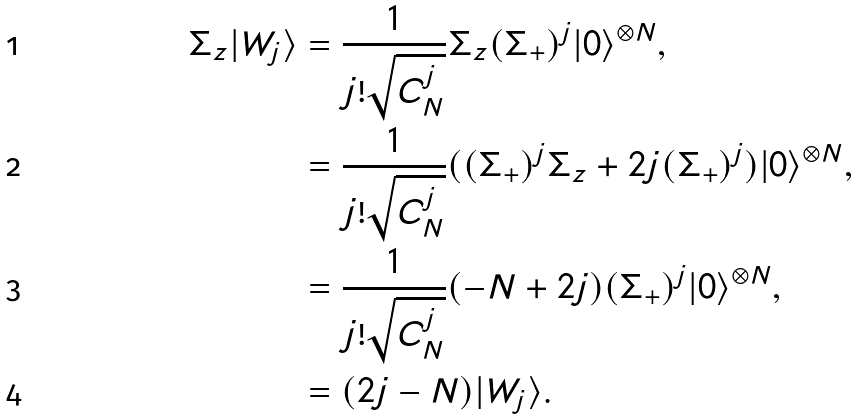<formula> <loc_0><loc_0><loc_500><loc_500>\Sigma _ { z } | W _ { j } \rangle & = \frac { 1 } { j ! \sqrt { C ^ { j } _ { N } } } \Sigma _ { z } ( \Sigma _ { + } ) ^ { j } | 0 \rangle ^ { \otimes N } , \\ & = \frac { 1 } { j ! \sqrt { C ^ { j } _ { N } } } ( ( \Sigma _ { + } ) ^ { j } \Sigma _ { z } + 2 j ( \Sigma _ { + } ) ^ { j } ) | 0 \rangle ^ { \otimes N } , \\ & = \frac { 1 } { j ! \sqrt { C ^ { j } _ { N } } } ( - N + 2 j ) ( \Sigma _ { + } ) ^ { j } | 0 \rangle ^ { \otimes N } , \\ & = ( 2 j - N ) | W _ { j } \rangle .</formula> 